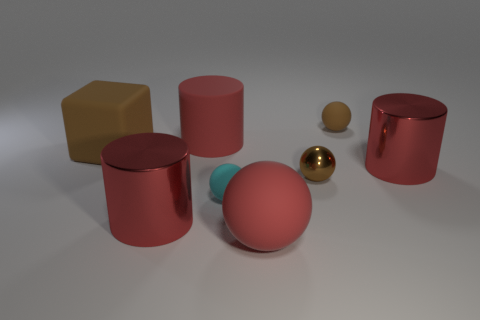How many things are either big red cylinders behind the block or blocks?
Make the answer very short. 2. How many red matte objects are to the right of the red rubber object behind the large block?
Give a very brief answer. 1. Is the number of large matte things that are on the right side of the matte block less than the number of large red metal objects in front of the large matte sphere?
Your answer should be compact. No. There is a shiny object right of the small metallic thing that is on the right side of the large red matte sphere; what shape is it?
Provide a succinct answer. Cylinder. Is there anything else that is the same size as the metallic ball?
Give a very brief answer. Yes. Is the number of brown things greater than the number of large matte cubes?
Offer a very short reply. Yes. There is a red matte thing behind the brown sphere that is on the left side of the tiny matte thing that is on the right side of the red rubber ball; what size is it?
Your answer should be very brief. Large. There is a brown rubber sphere; is it the same size as the brown object that is to the left of the red sphere?
Make the answer very short. No. Is the number of red cylinders behind the big rubber cylinder less than the number of big balls?
Offer a very short reply. Yes. How many other metal spheres are the same color as the large ball?
Offer a terse response. 0. 